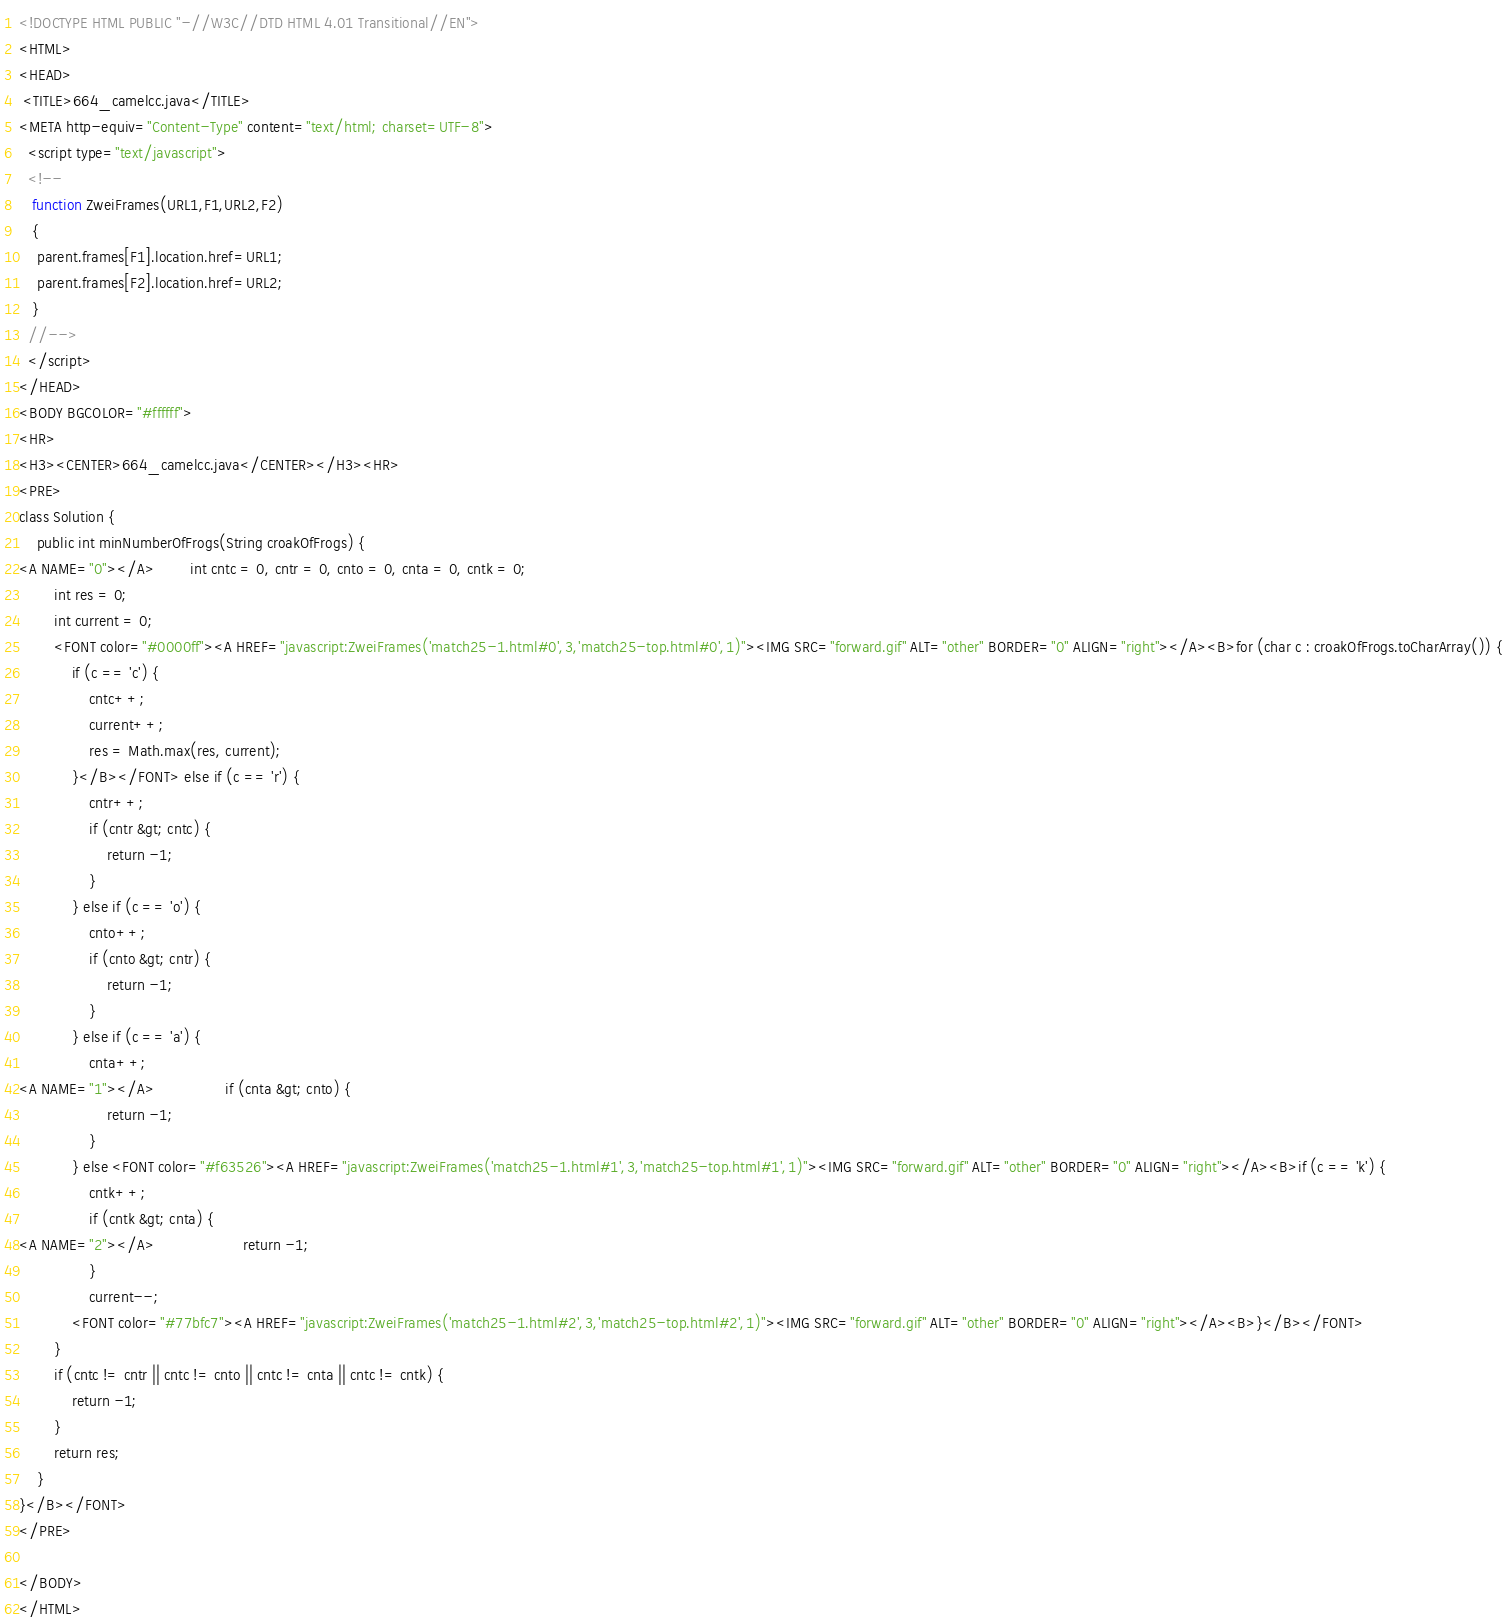<code> <loc_0><loc_0><loc_500><loc_500><_HTML_><!DOCTYPE HTML PUBLIC "-//W3C//DTD HTML 4.01 Transitional//EN">
<HTML>
<HEAD>
 <TITLE>664_camelcc.java</TITLE>
<META http-equiv="Content-Type" content="text/html; charset=UTF-8">
  <script type="text/javascript">
  <!--
   function ZweiFrames(URL1,F1,URL2,F2)
   {
    parent.frames[F1].location.href=URL1;
    parent.frames[F2].location.href=URL2;
   }
  //-->
  </script>
</HEAD>
<BODY BGCOLOR="#ffffff">
<HR>
<H3><CENTER>664_camelcc.java</CENTER></H3><HR>
<PRE>
class Solution {
    public int minNumberOfFrogs(String croakOfFrogs) {
<A NAME="0"></A>        int cntc = 0, cntr = 0, cnto = 0, cnta = 0, cntk = 0;
        int res = 0;
        int current = 0;
        <FONT color="#0000ff"><A HREF="javascript:ZweiFrames('match25-1.html#0',3,'match25-top.html#0',1)"><IMG SRC="forward.gif" ALT="other" BORDER="0" ALIGN="right"></A><B>for (char c : croakOfFrogs.toCharArray()) {
            if (c == 'c') {
                cntc++;
                current++;
                res = Math.max(res, current);
            }</B></FONT> else if (c == 'r') {
                cntr++;
                if (cntr &gt; cntc) {
                    return -1;
                }
            } else if (c == 'o') {
                cnto++;
                if (cnto &gt; cntr) {
                    return -1;
                }
            } else if (c == 'a') {
                cnta++;
<A NAME="1"></A>                if (cnta &gt; cnto) {
                    return -1;
                }
            } else <FONT color="#f63526"><A HREF="javascript:ZweiFrames('match25-1.html#1',3,'match25-top.html#1',1)"><IMG SRC="forward.gif" ALT="other" BORDER="0" ALIGN="right"></A><B>if (c == 'k') {
                cntk++;
                if (cntk &gt; cnta) {
<A NAME="2"></A>                    return -1;
                }
                current--;
            <FONT color="#77bfc7"><A HREF="javascript:ZweiFrames('match25-1.html#2',3,'match25-top.html#2',1)"><IMG SRC="forward.gif" ALT="other" BORDER="0" ALIGN="right"></A><B>}</B></FONT>
        }
        if (cntc != cntr || cntc != cnto || cntc != cnta || cntc != cntk) {
            return -1;
        }
        return res;        
    }
}</B></FONT>
</PRE>

</BODY>
</HTML>
</code> 